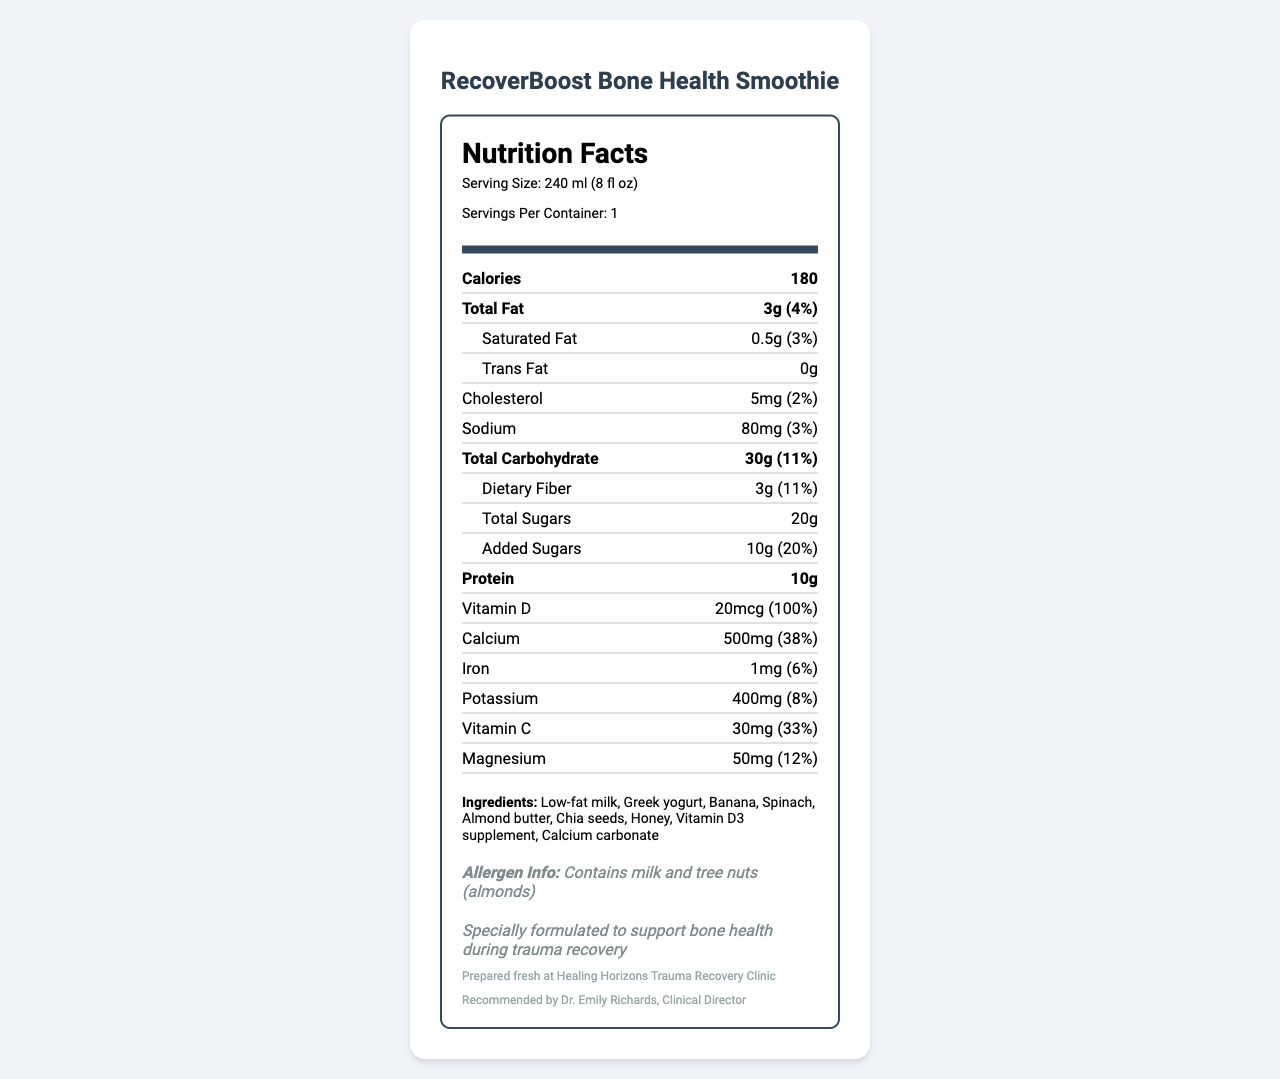what is the serving size of RecoverBoost Bone Health Smoothie? The serving size is clearly listed under the "Serving Size" section of the Nutrition Facts label.
Answer: 240 ml (8 fl oz) how many calories are in one serving of the smoothie? The calorie count is prominently displayed in large font at the top of the Nutrition Facts label.
Answer: 180 what is the amount of protein per serving? The protein content is listed in the Nutrition Facts section under "Protein."
Answer: 10g how much calcium does the smoothie provide per serving? The calcium content is found in the Nutrition Facts section where it lists "Calcium."
Answer: 500mg (38% daily value) list the allergies that are present in this product. The allergen information is listed toward the bottom of the document under "Allergen Info."
Answer: Contains milk and tree nuts (almonds) how much dietary fiber does this product contain? The dietary fiber content can be found under "Total Carbohydrate" in the Nutrition Facts section.
Answer: 3g (11% daily value) what ingredients are used in the smoothie? The list of ingredients is located toward the bottom of the document under "Ingredients."
Answer: Low-fat milk, Greek yogurt, Banana, Spinach, Almond butter, Chia seeds, Honey, Vitamin D3 supplement, Calcium carbonate what is the total amount of sugars in the smoothie, including added sugars? Under the "Total Sugars" section, it lists "20g" and "Added Sugars" specifically as "10g."
Answer: 20g total, with 10g added sugars how much Vitamin D does the smoothie provide? The amount of Vitamin D is listed in the Nutrition Facts section under "Vitamin D."
Answer: 20mcg (100% daily value) which nutrient has the highest percentage of daily value? A. Dietary Fiber B. Calcium C. Vitamin D D. Vitamin C Vitamin D is listed as providing 100% of the daily value.
Answer: C. Vitamin D how many servings are in one container? A. 1 B. 2 C. 3 D. 4 The document states "Servings Per Container: 1" at the top under serving information.
Answer: A. 1 is the smoothie recommended by a clinical director? The document states, "Recommended by Dr. Emily Richards, Clinical Director" toward the bottom.
Answer: Yes summarize the main purpose of the RecoverBoost Bone Health Smoothie. The document provides details on the nutritional content, ingredients, and specialized note about supporting bone health during trauma recovery.
Answer: It is a vitamin D and calcium-enriched smoothie designed to promote bone health during trauma recovery. It contains essential nutrients, is recommended by a clinical director, and includes ingredients beneficial for overall health. does the smoothie contain any iron? If so, how much? Iron content is listed in the Nutrition Facts section under "Iron."
Answer: Yes, 1mg (6% daily value) what are the primary sources of calcium and vitamin D in the smoothie? The specific primary sources of calcium and vitamin D (such as the exact supplement brands or forms) are not detailed in the document. We know there are "Vitamin D3 supplement" and "Calcium carbonate," but specific sources are unknown.
Answer: I don't know 